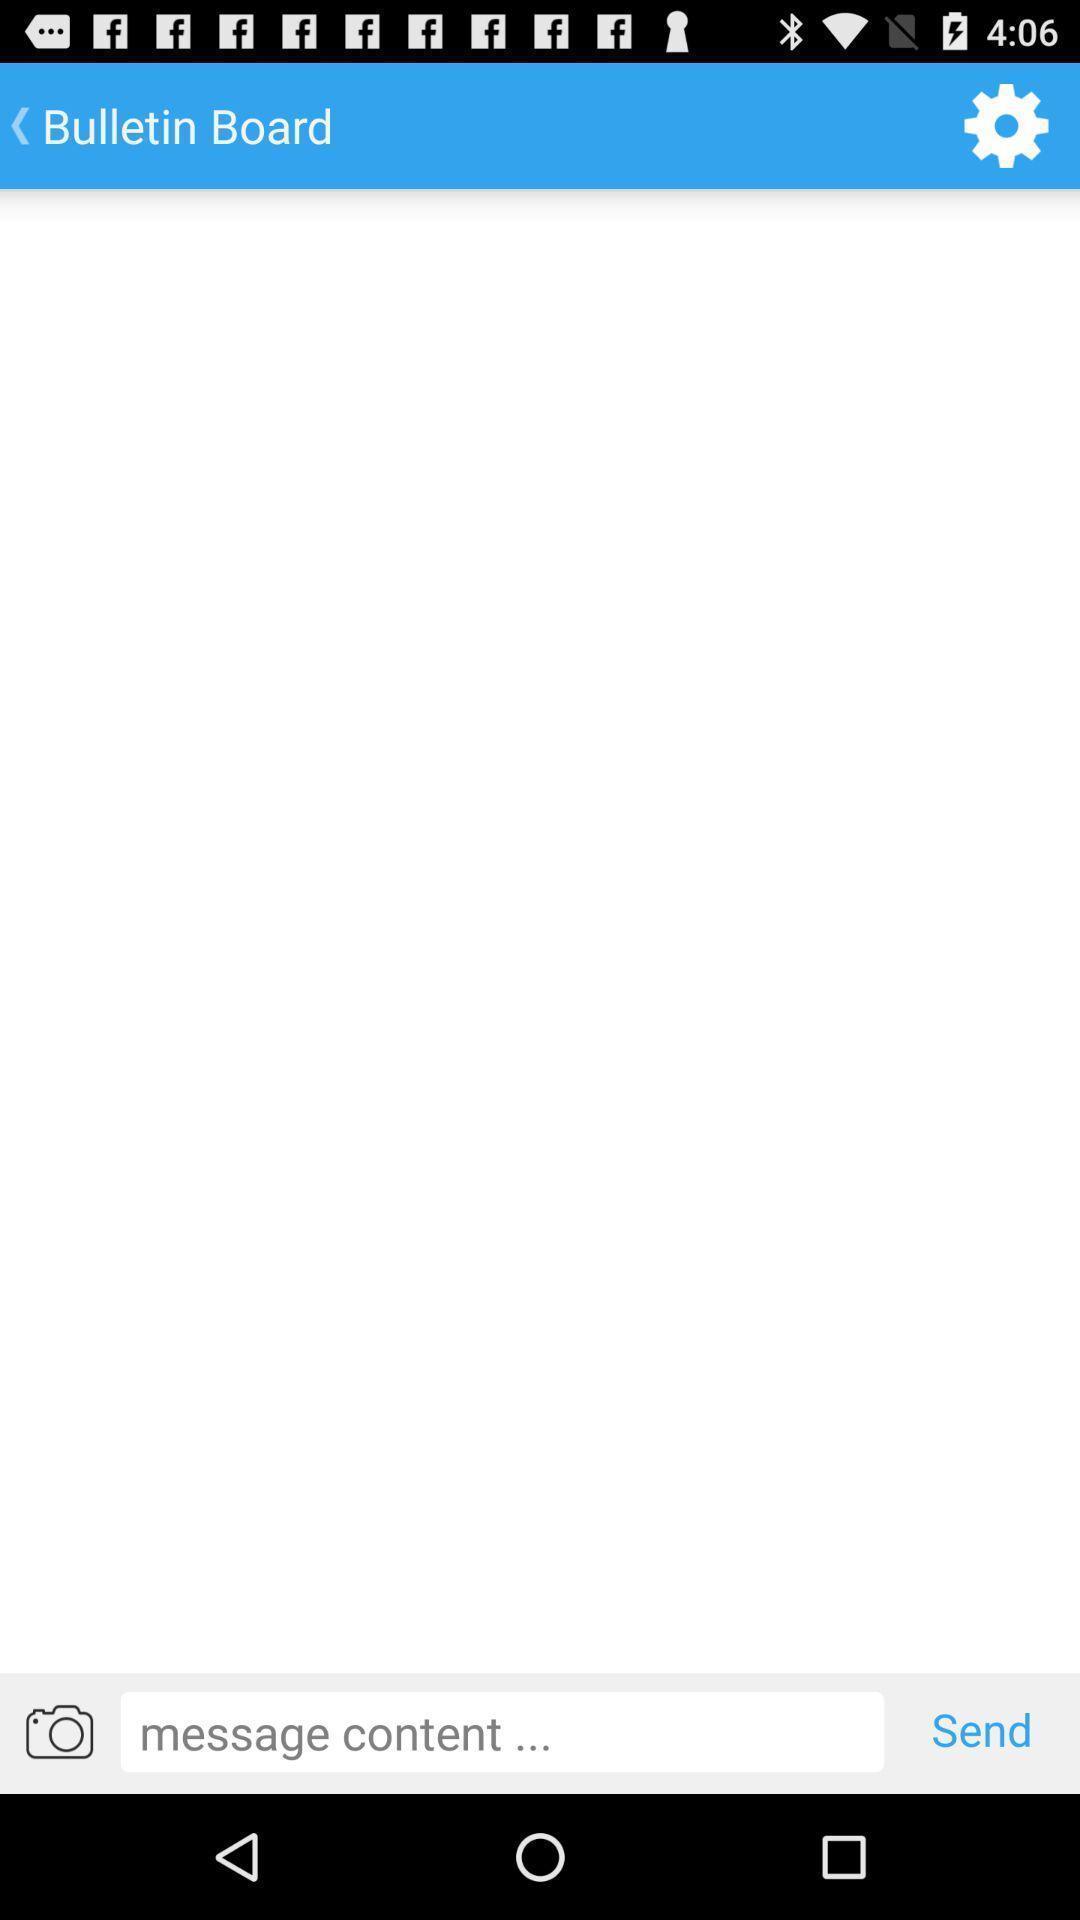Describe the content in this image. Page with settings and to send messages. 